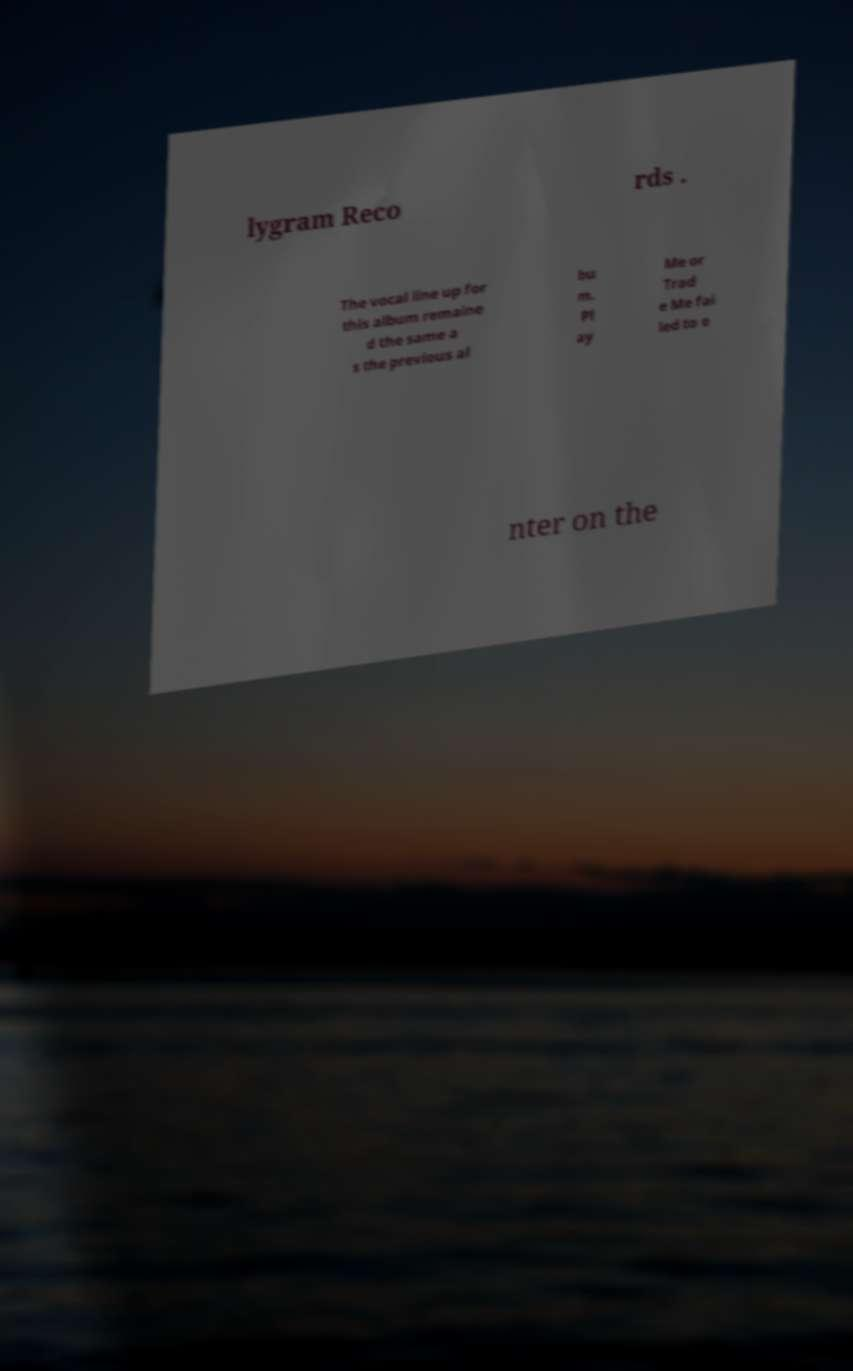Please read and relay the text visible in this image. What does it say? lygram Reco rds . The vocal line up for this album remaine d the same a s the previous al bu m. Pl ay Me or Trad e Me fai led to e nter on the 